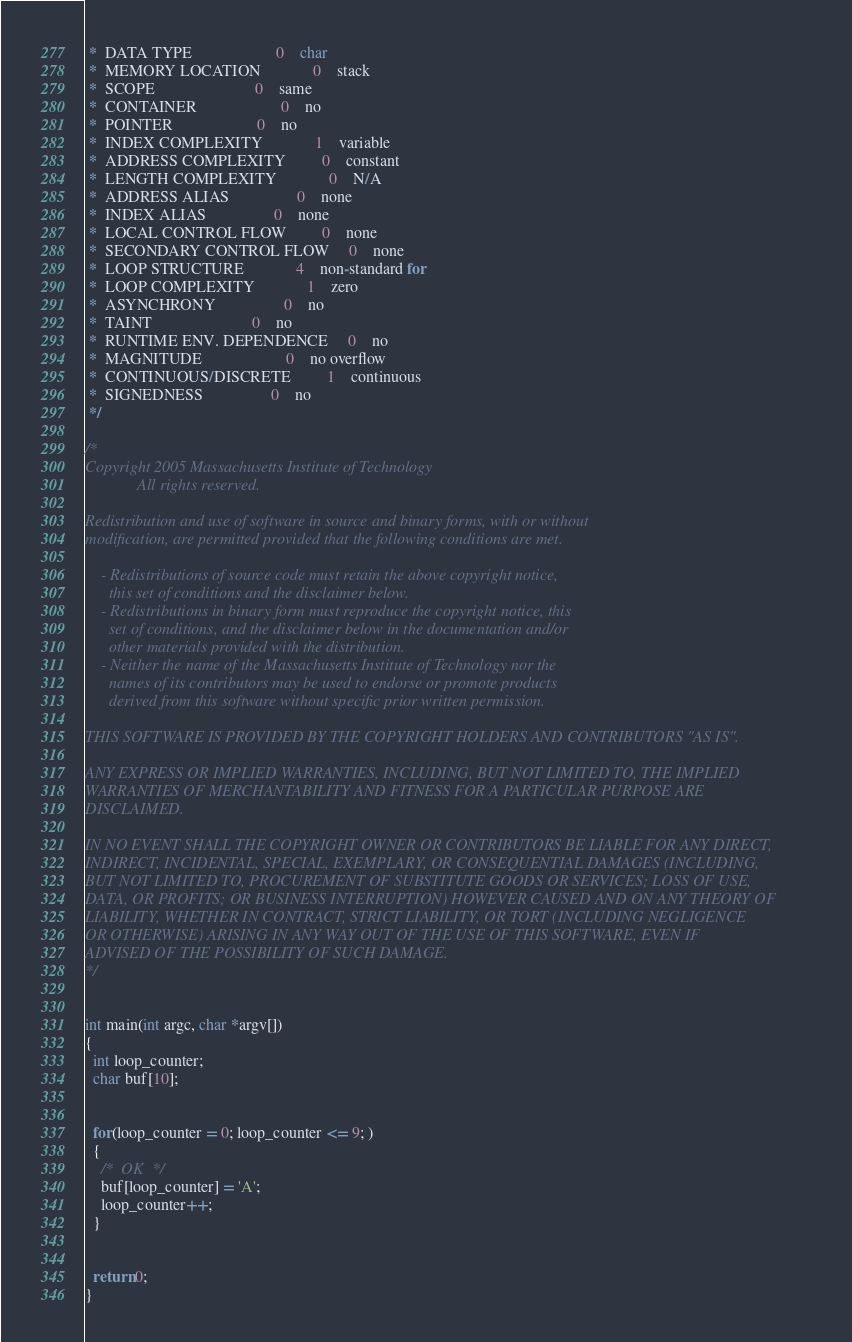Convert code to text. <code><loc_0><loc_0><loc_500><loc_500><_C_> *  DATA TYPE                	 0	char
 *  MEMORY LOCATION          	 0	stack
 *  SCOPE                    	 0	same
 *  CONTAINER                	 0	no
 *  POINTER                  	 0	no
 *  INDEX COMPLEXITY         	 1	variable
 *  ADDRESS COMPLEXITY       	 0	constant
 *  LENGTH COMPLEXITY        	 0	N/A
 *  ADDRESS ALIAS            	 0	none
 *  INDEX ALIAS              	 0	none
 *  LOCAL CONTROL FLOW       	 0	none
 *  SECONDARY CONTROL FLOW   	 0	none
 *  LOOP STRUCTURE           	 4	non-standard for
 *  LOOP COMPLEXITY          	 1	zero
 *  ASYNCHRONY               	 0	no
 *  TAINT                    	 0	no
 *  RUNTIME ENV. DEPENDENCE  	 0	no
 *  MAGNITUDE                	 0	no overflow
 *  CONTINUOUS/DISCRETE      	 1	continuous
 *  SIGNEDNESS               	 0	no
 */

/*
Copyright 2005 Massachusetts Institute of Technology
             All rights reserved. 

Redistribution and use of software in source and binary forms, with or without 
modification, are permitted provided that the following conditions are met.

    - Redistributions of source code must retain the above copyright notice, 
      this set of conditions and the disclaimer below.
    - Redistributions in binary form must reproduce the copyright notice, this 
      set of conditions, and the disclaimer below in the documentation and/or 
      other materials provided with the distribution.
    - Neither the name of the Massachusetts Institute of Technology nor the 
      names of its contributors may be used to endorse or promote products 
      derived from this software without specific prior written permission. 

THIS SOFTWARE IS PROVIDED BY THE COPYRIGHT HOLDERS AND CONTRIBUTORS "AS IS".

ANY EXPRESS OR IMPLIED WARRANTIES, INCLUDING, BUT NOT LIMITED TO, THE IMPLIED 
WARRANTIES OF MERCHANTABILITY AND FITNESS FOR A PARTICULAR PURPOSE ARE 
DISCLAIMED. 

IN NO EVENT SHALL THE COPYRIGHT OWNER OR CONTRIBUTORS BE LIABLE FOR ANY DIRECT,
INDIRECT, INCIDENTAL, SPECIAL, EXEMPLARY, OR CONSEQUENTIAL DAMAGES (INCLUDING, 
BUT NOT LIMITED TO, PROCUREMENT OF SUBSTITUTE GOODS OR SERVICES; LOSS OF USE, 
DATA, OR PROFITS; OR BUSINESS INTERRUPTION) HOWEVER CAUSED AND ON ANY THEORY OF
LIABILITY, WHETHER IN CONTRACT, STRICT LIABILITY, OR TORT (INCLUDING NEGLIGENCE 
OR OTHERWISE) ARISING IN ANY WAY OUT OF THE USE OF THIS SOFTWARE, EVEN IF 
ADVISED OF THE POSSIBILITY OF SUCH DAMAGE. 
*/


int main(int argc, char *argv[])
{
  int loop_counter;
  char buf[10];


  for(loop_counter = 0; loop_counter <= 9; )
  {
    /*  OK  */
    buf[loop_counter] = 'A';
    loop_counter++;
  }


  return 0;
}
</code> 